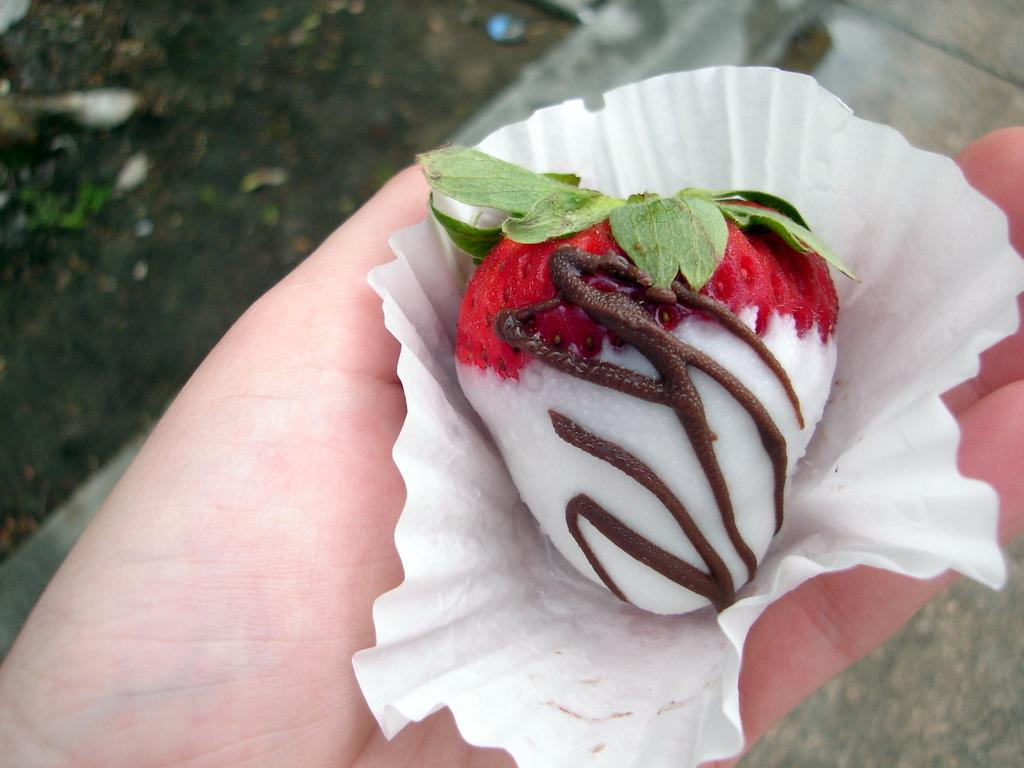What is the main food item featured in the image? There is a strawberry with chocolate on it in the image. What is the strawberry placed on? The strawberry is on a paper. Who is holding the paper with the strawberry? The paper is held in a person's hand. What can be seen in the background of the image? There is soil visible in the background of the image. What plot twist occurs in the image involving a surprise? There is no plot or surprise present in the image; it is a simple depiction of a strawberry with chocolate on a paper held by a person. 